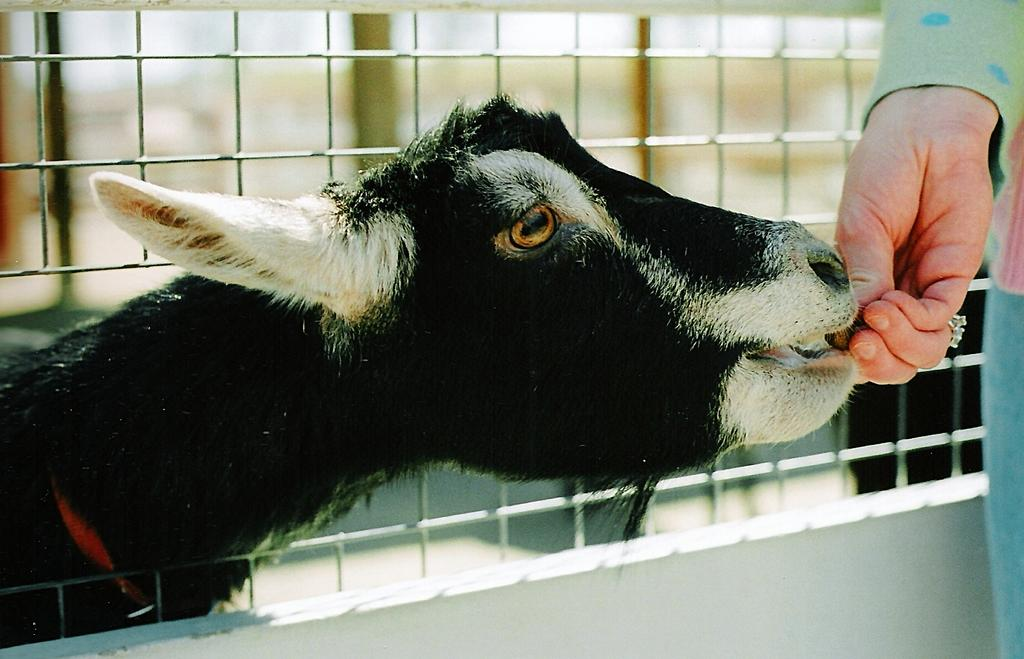Who is present in the image? There is a person in the image. What is the person doing in the image? The person is feeding a goat. Where is the goat located in the image? The goat is in the middle of the image. What can be seen in the background of the image? There is fencing in the background of the image. How many boats are visible in the image? There are no boats present in the image. What type of bead is being used to feed the goat in the image? The person is feeding the goat with food, not a bead, so there is no bead involved in the image. 